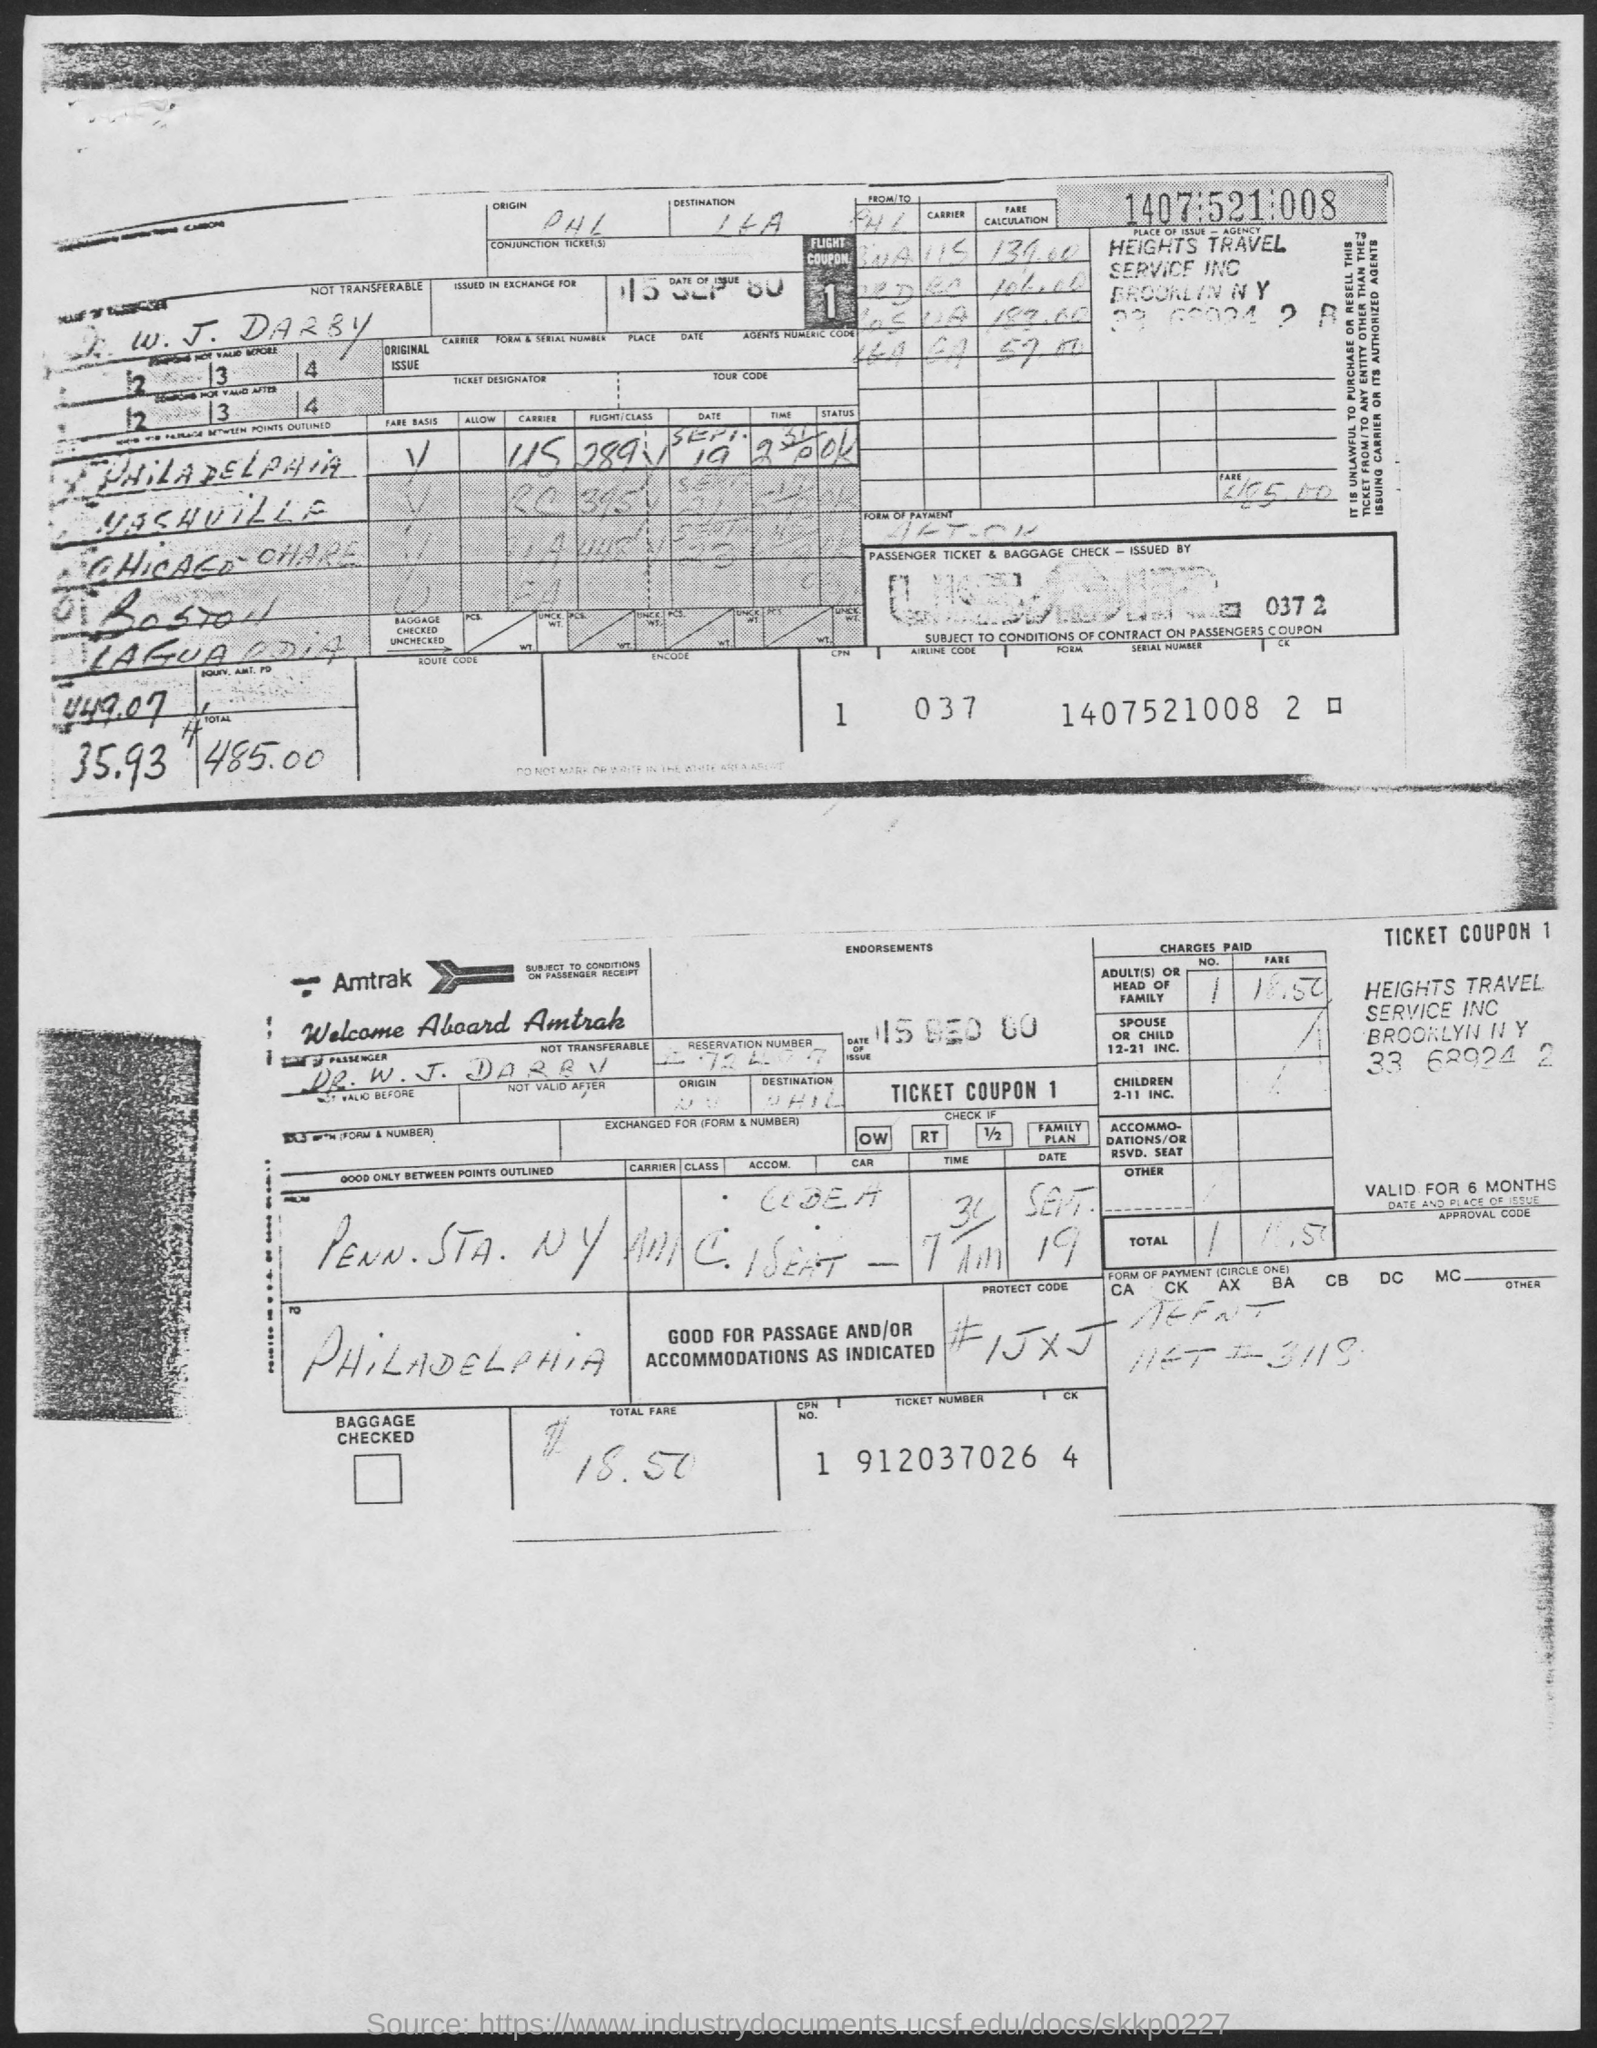What is the date of issue mentioned in the given form ?
Provide a succinct answer. 15 SEP 80. What is the airline code mentioned in the given form ?
Ensure brevity in your answer.  037. What is the ticket number mentioned in the given form ?
Make the answer very short. 912037026. 